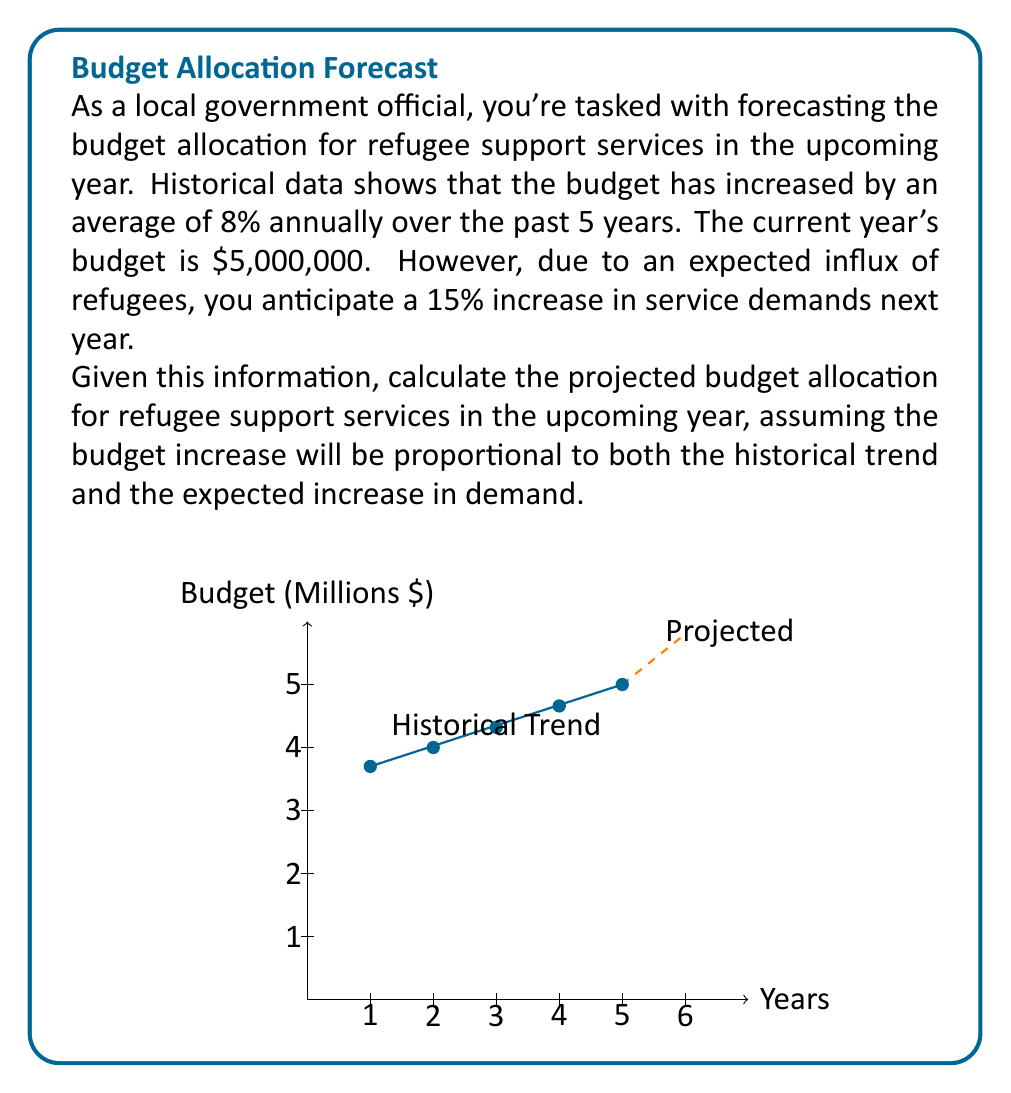Solve this math problem. Let's approach this problem step-by-step:

1) First, we need to calculate the combined effect of the historical trend and the expected increase in demand:
   - Historical trend: 8% increase
   - Expected increase in demand: 15% increase

2) To combine these effects, we multiply the factors:
   $$(1 + 0.08) \times (1 + 0.15) = 1.08 \times 1.15 = 1.242$$

3) This means we expect a total increase of 24.2% (1.242 - 1 = 0.242)

4) Now, let's apply this increase to the current year's budget:
   
   $$\text{Next Year's Budget} = \text{Current Budget} \times (1 + \text{Total Increase})$$
   $$= \$5,000,000 \times 1.242$$

5) Let's calculate this:
   $$\$5,000,000 \times 1.242 = \$6,210,000$$

Therefore, the projected budget allocation for refugee support services in the upcoming year is $6,210,000.
Answer: $6,210,000 